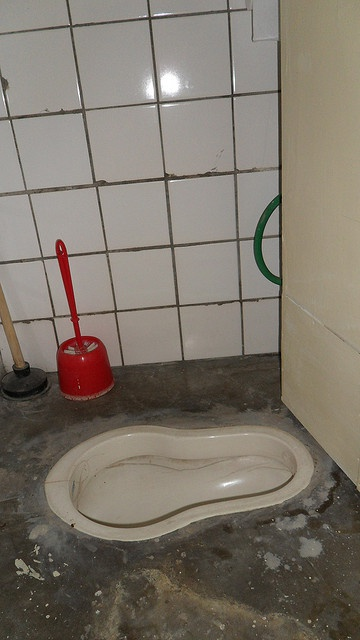Describe the objects in this image and their specific colors. I can see a toilet in gray and darkgray tones in this image. 